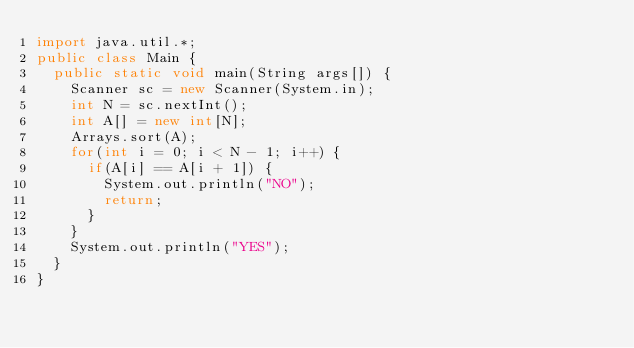<code> <loc_0><loc_0><loc_500><loc_500><_Java_>import java.util.*;
public class Main {
	public static void main(String args[]) {
		Scanner sc = new Scanner(System.in);
		int N = sc.nextInt();
		int A[] = new int[N];
		Arrays.sort(A);
		for(int i = 0; i < N - 1; i++) {
			if(A[i] == A[i + 1]) {
				System.out.println("NO");
				return;
			}
		}
		System.out.println("YES");
	}
}
</code> 